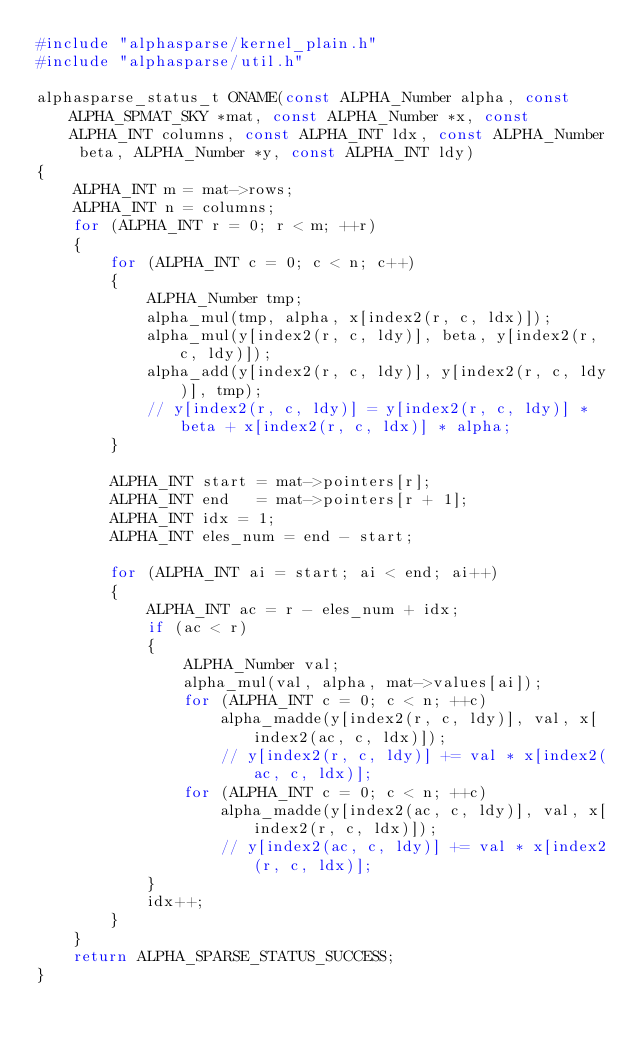Convert code to text. <code><loc_0><loc_0><loc_500><loc_500><_C_>#include "alphasparse/kernel_plain.h"
#include "alphasparse/util.h"

alphasparse_status_t ONAME(const ALPHA_Number alpha, const ALPHA_SPMAT_SKY *mat, const ALPHA_Number *x, const ALPHA_INT columns, const ALPHA_INT ldx, const ALPHA_Number beta, ALPHA_Number *y, const ALPHA_INT ldy)
{
    ALPHA_INT m = mat->rows;
    ALPHA_INT n = columns;
    for (ALPHA_INT r = 0; r < m; ++r)
    {
        for (ALPHA_INT c = 0; c < n; c++)
        {
            ALPHA_Number tmp;
            alpha_mul(tmp, alpha, x[index2(r, c, ldx)]);
            alpha_mul(y[index2(r, c, ldy)], beta, y[index2(r, c, ldy)]);
            alpha_add(y[index2(r, c, ldy)], y[index2(r, c, ldy)], tmp);
            // y[index2(r, c, ldy)] = y[index2(r, c, ldy)] * beta + x[index2(r, c, ldx)] * alpha;
        }

        ALPHA_INT start = mat->pointers[r];
        ALPHA_INT end   = mat->pointers[r + 1];
        ALPHA_INT idx = 1;
        ALPHA_INT eles_num = end - start;

        for (ALPHA_INT ai = start; ai < end; ai++)
        {
            ALPHA_INT ac = r - eles_num + idx;
            if (ac < r)
            {
                ALPHA_Number val;
                alpha_mul(val, alpha, mat->values[ai]);
                for (ALPHA_INT c = 0; c < n; ++c)
                    alpha_madde(y[index2(r, c, ldy)], val, x[index2(ac, c, ldx)]);
                    // y[index2(r, c, ldy)] += val * x[index2(ac, c, ldx)];
                for (ALPHA_INT c = 0; c < n; ++c)
                    alpha_madde(y[index2(ac, c, ldy)], val, x[index2(r, c, ldx)]);
                    // y[index2(ac, c, ldy)] += val * x[index2(r, c, ldx)];
            }
            idx++;
        }
    }
    return ALPHA_SPARSE_STATUS_SUCCESS;
}
</code> 